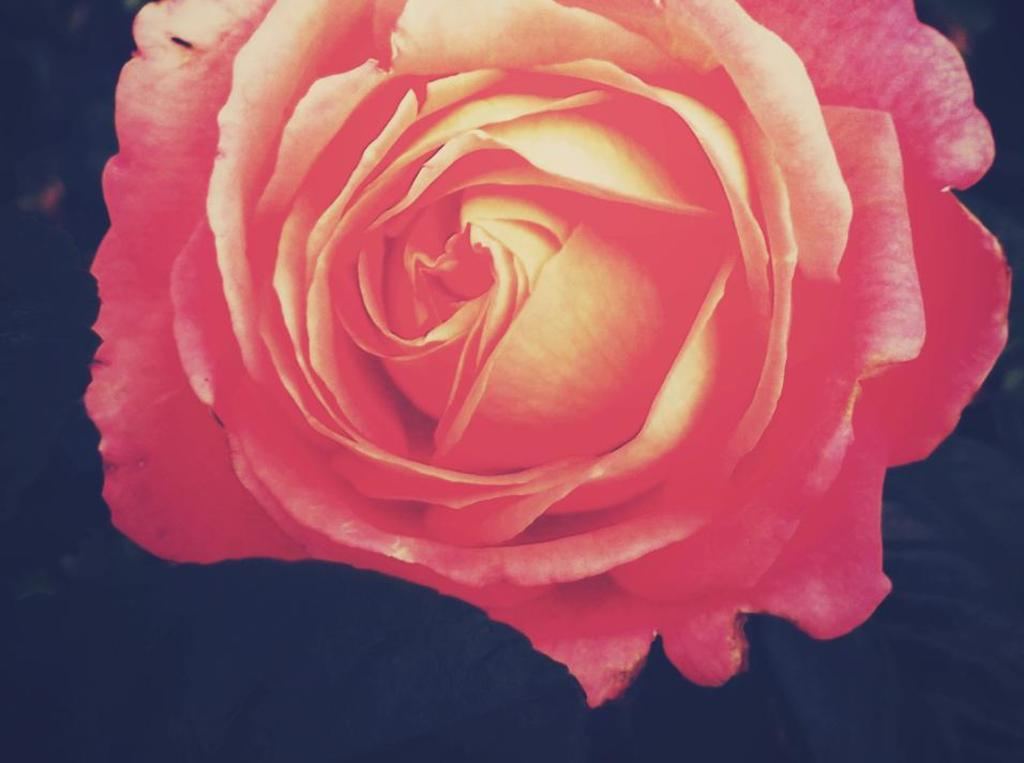What type of flower is in the image? There is a rose flower in the image. What can be observed about the background of the image? The background of the image is dark. What type of activity is taking place in the image? There is no specific activity taking place in the image; it primarily features a rose flower against a dark background. 